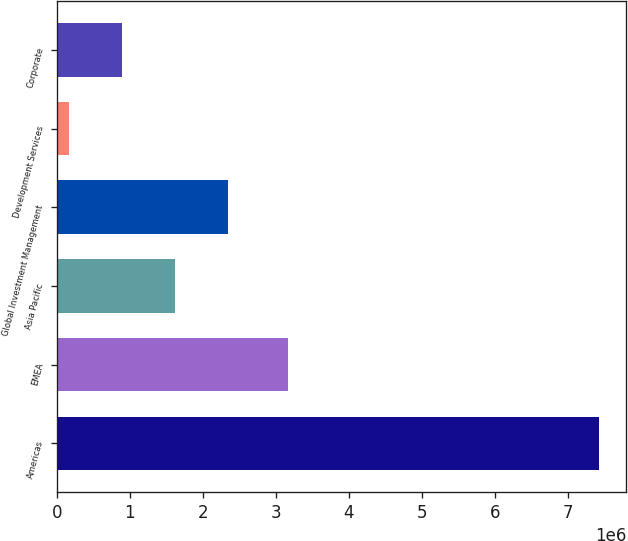<chart> <loc_0><loc_0><loc_500><loc_500><bar_chart><fcel>Americas<fcel>EMEA<fcel>Asia Pacific<fcel>Global Investment Management<fcel>Development Services<fcel>Corporate<nl><fcel>7.43253e+06<fcel>3.16805e+06<fcel>1.62e+06<fcel>2.34656e+06<fcel>166864<fcel>893431<nl></chart> 